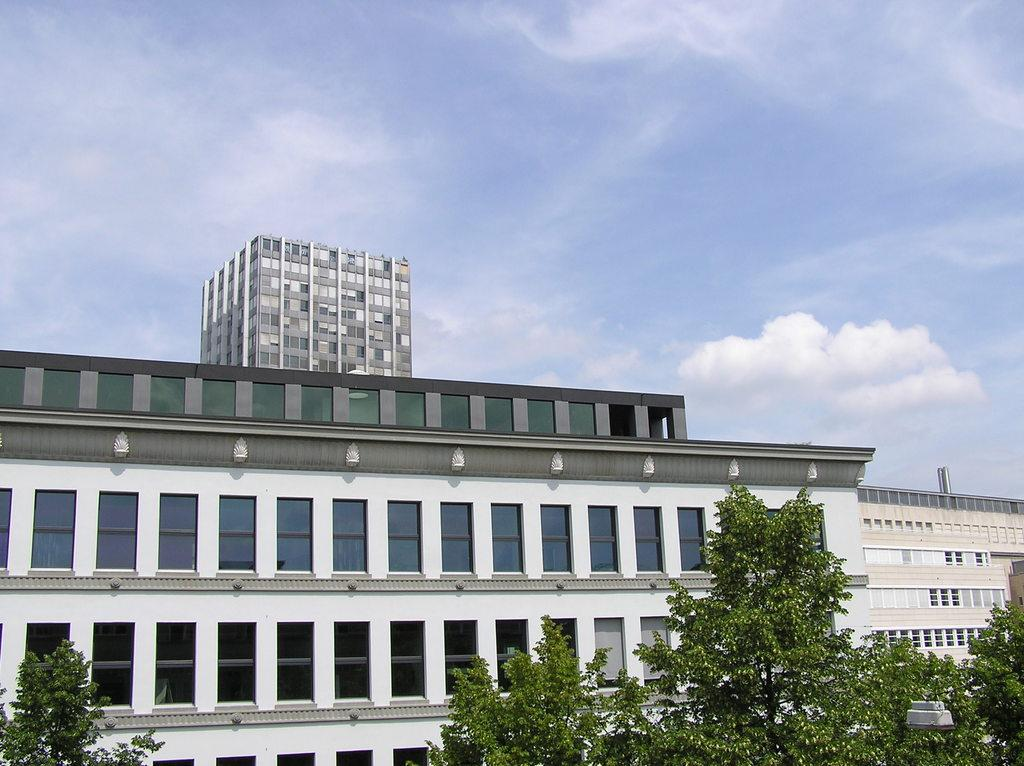What type of structures can be seen in the image? There are buildings in the image. What other natural elements are present in the image? There are trees in the image. What is visible in the background of the image? The sky is visible in the image. What can be observed in the sky? Clouds are present in the sky. What type of growth can be seen on the governor's head in the image? There is no governor present in the image, and therefore no growth can be observed on their head. What type of star is visible in the image? There is no star visible in the image; it features buildings, trees, sky, and clouds. 